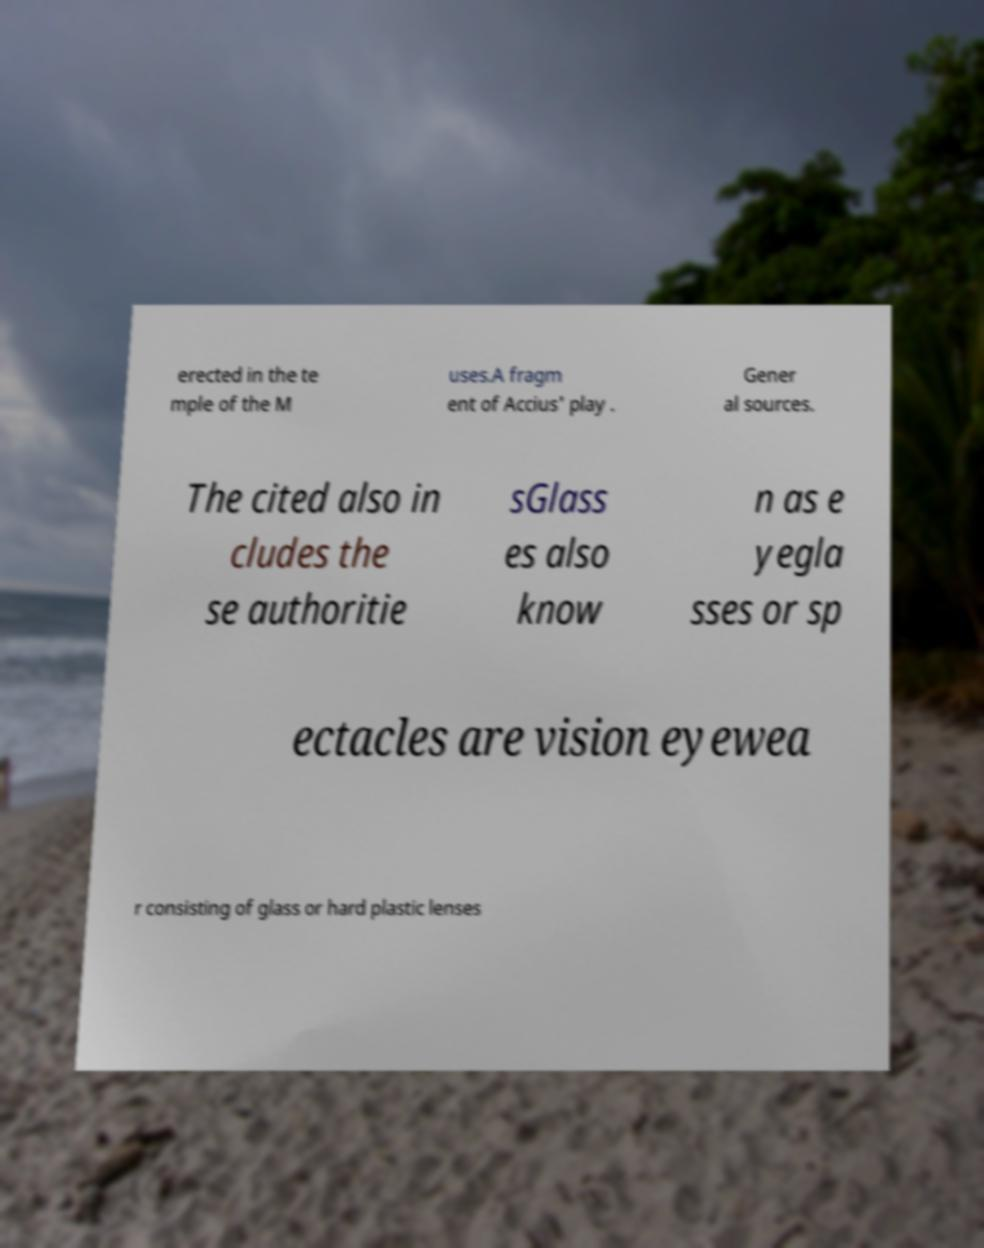I need the written content from this picture converted into text. Can you do that? erected in the te mple of the M uses.A fragm ent of Accius' play . Gener al sources. The cited also in cludes the se authoritie sGlass es also know n as e yegla sses or sp ectacles are vision eyewea r consisting of glass or hard plastic lenses 